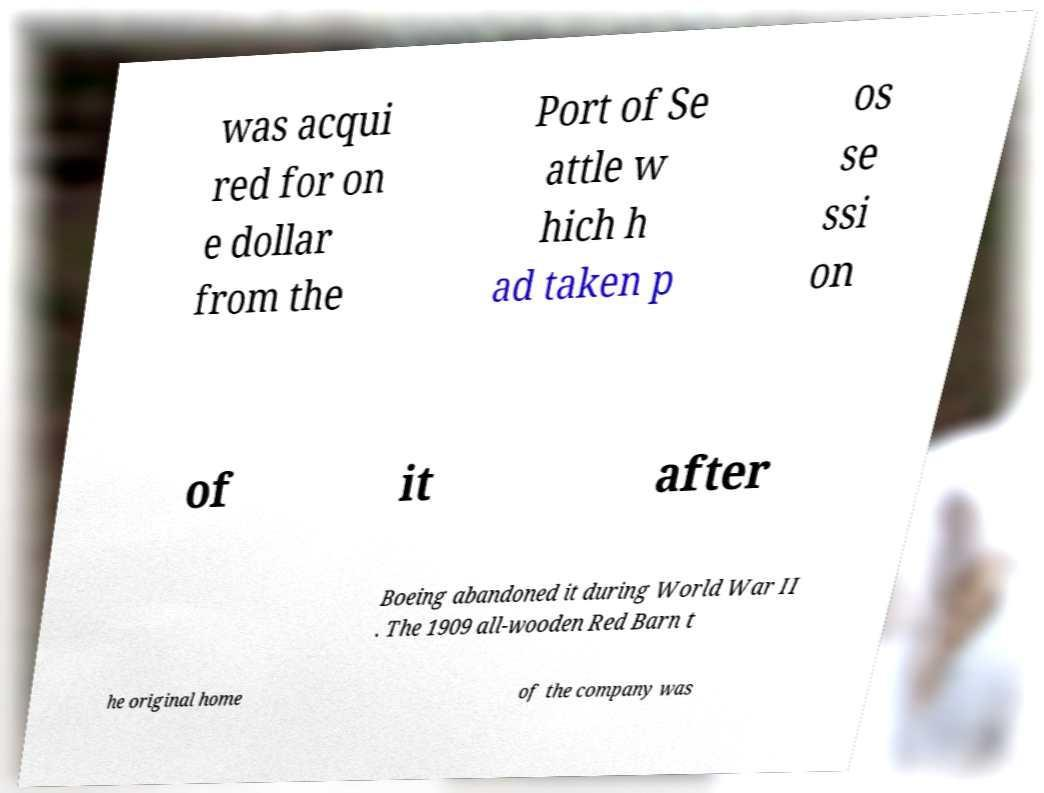Please read and relay the text visible in this image. What does it say? was acqui red for on e dollar from the Port of Se attle w hich h ad taken p os se ssi on of it after Boeing abandoned it during World War II . The 1909 all-wooden Red Barn t he original home of the company was 